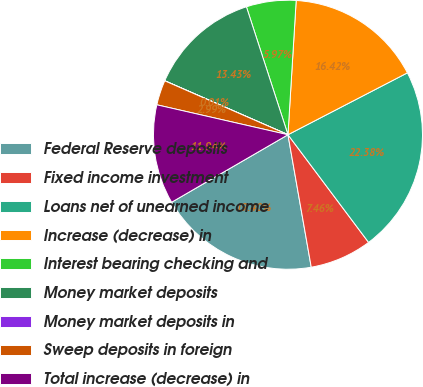Convert chart to OTSL. <chart><loc_0><loc_0><loc_500><loc_500><pie_chart><fcel>Federal Reserve deposits<fcel>Fixed income investment<fcel>Loans net of unearned income<fcel>Increase (decrease) in<fcel>Interest bearing checking and<fcel>Money market deposits<fcel>Money market deposits in<fcel>Sweep deposits in foreign<fcel>Total increase (decrease) in<nl><fcel>19.4%<fcel>7.46%<fcel>22.38%<fcel>16.42%<fcel>5.97%<fcel>13.43%<fcel>0.01%<fcel>2.99%<fcel>11.94%<nl></chart> 